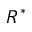Convert formula to latex. <formula><loc_0><loc_0><loc_500><loc_500>R ^ { * }</formula> 